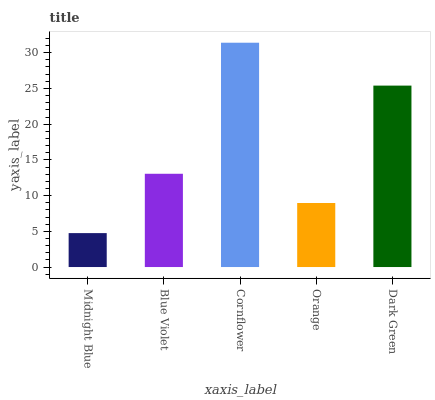Is Midnight Blue the minimum?
Answer yes or no. Yes. Is Cornflower the maximum?
Answer yes or no. Yes. Is Blue Violet the minimum?
Answer yes or no. No. Is Blue Violet the maximum?
Answer yes or no. No. Is Blue Violet greater than Midnight Blue?
Answer yes or no. Yes. Is Midnight Blue less than Blue Violet?
Answer yes or no. Yes. Is Midnight Blue greater than Blue Violet?
Answer yes or no. No. Is Blue Violet less than Midnight Blue?
Answer yes or no. No. Is Blue Violet the high median?
Answer yes or no. Yes. Is Blue Violet the low median?
Answer yes or no. Yes. Is Dark Green the high median?
Answer yes or no. No. Is Midnight Blue the low median?
Answer yes or no. No. 